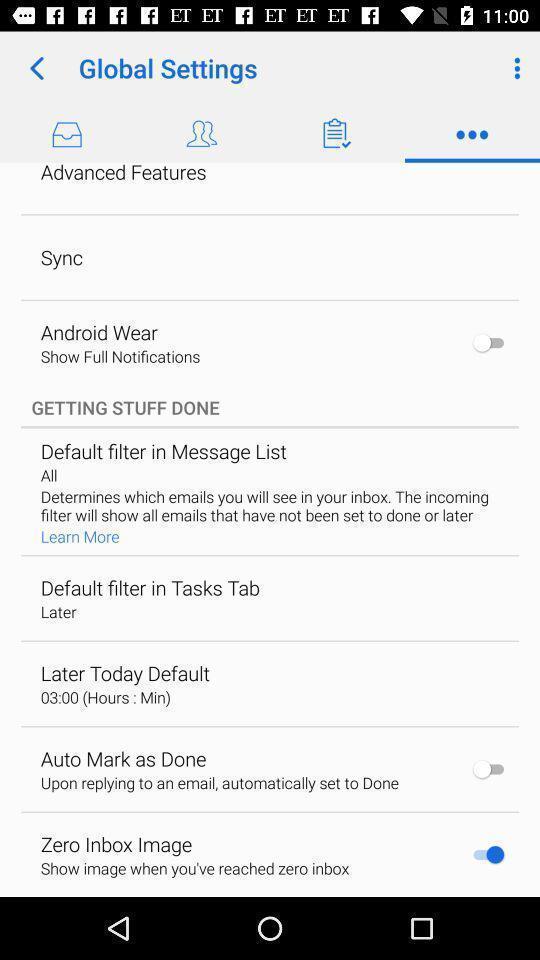Give me a narrative description of this picture. Settings page in an email app. 